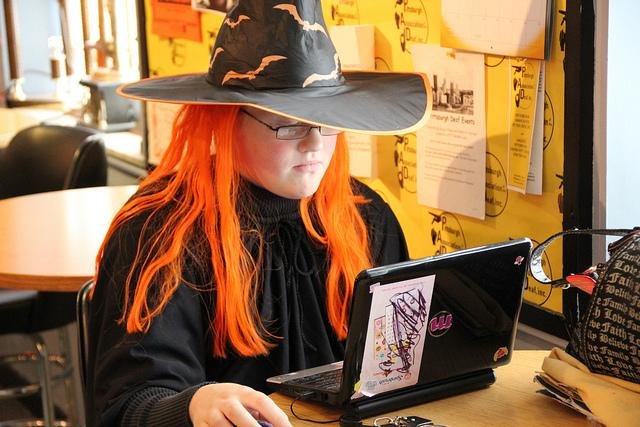What hat does the woman have on? witch hat 